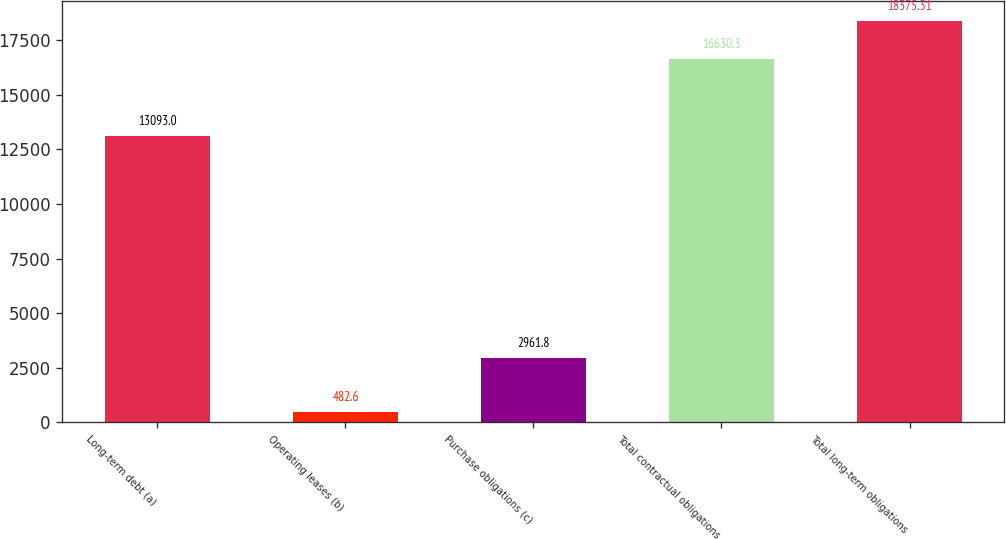Convert chart to OTSL. <chart><loc_0><loc_0><loc_500><loc_500><bar_chart><fcel>Long-term debt (a)<fcel>Operating leases (b)<fcel>Purchase obligations (c)<fcel>Total contractual obligations<fcel>Total long-term obligations<nl><fcel>13093<fcel>482.6<fcel>2961.8<fcel>16630.3<fcel>18375.3<nl></chart> 